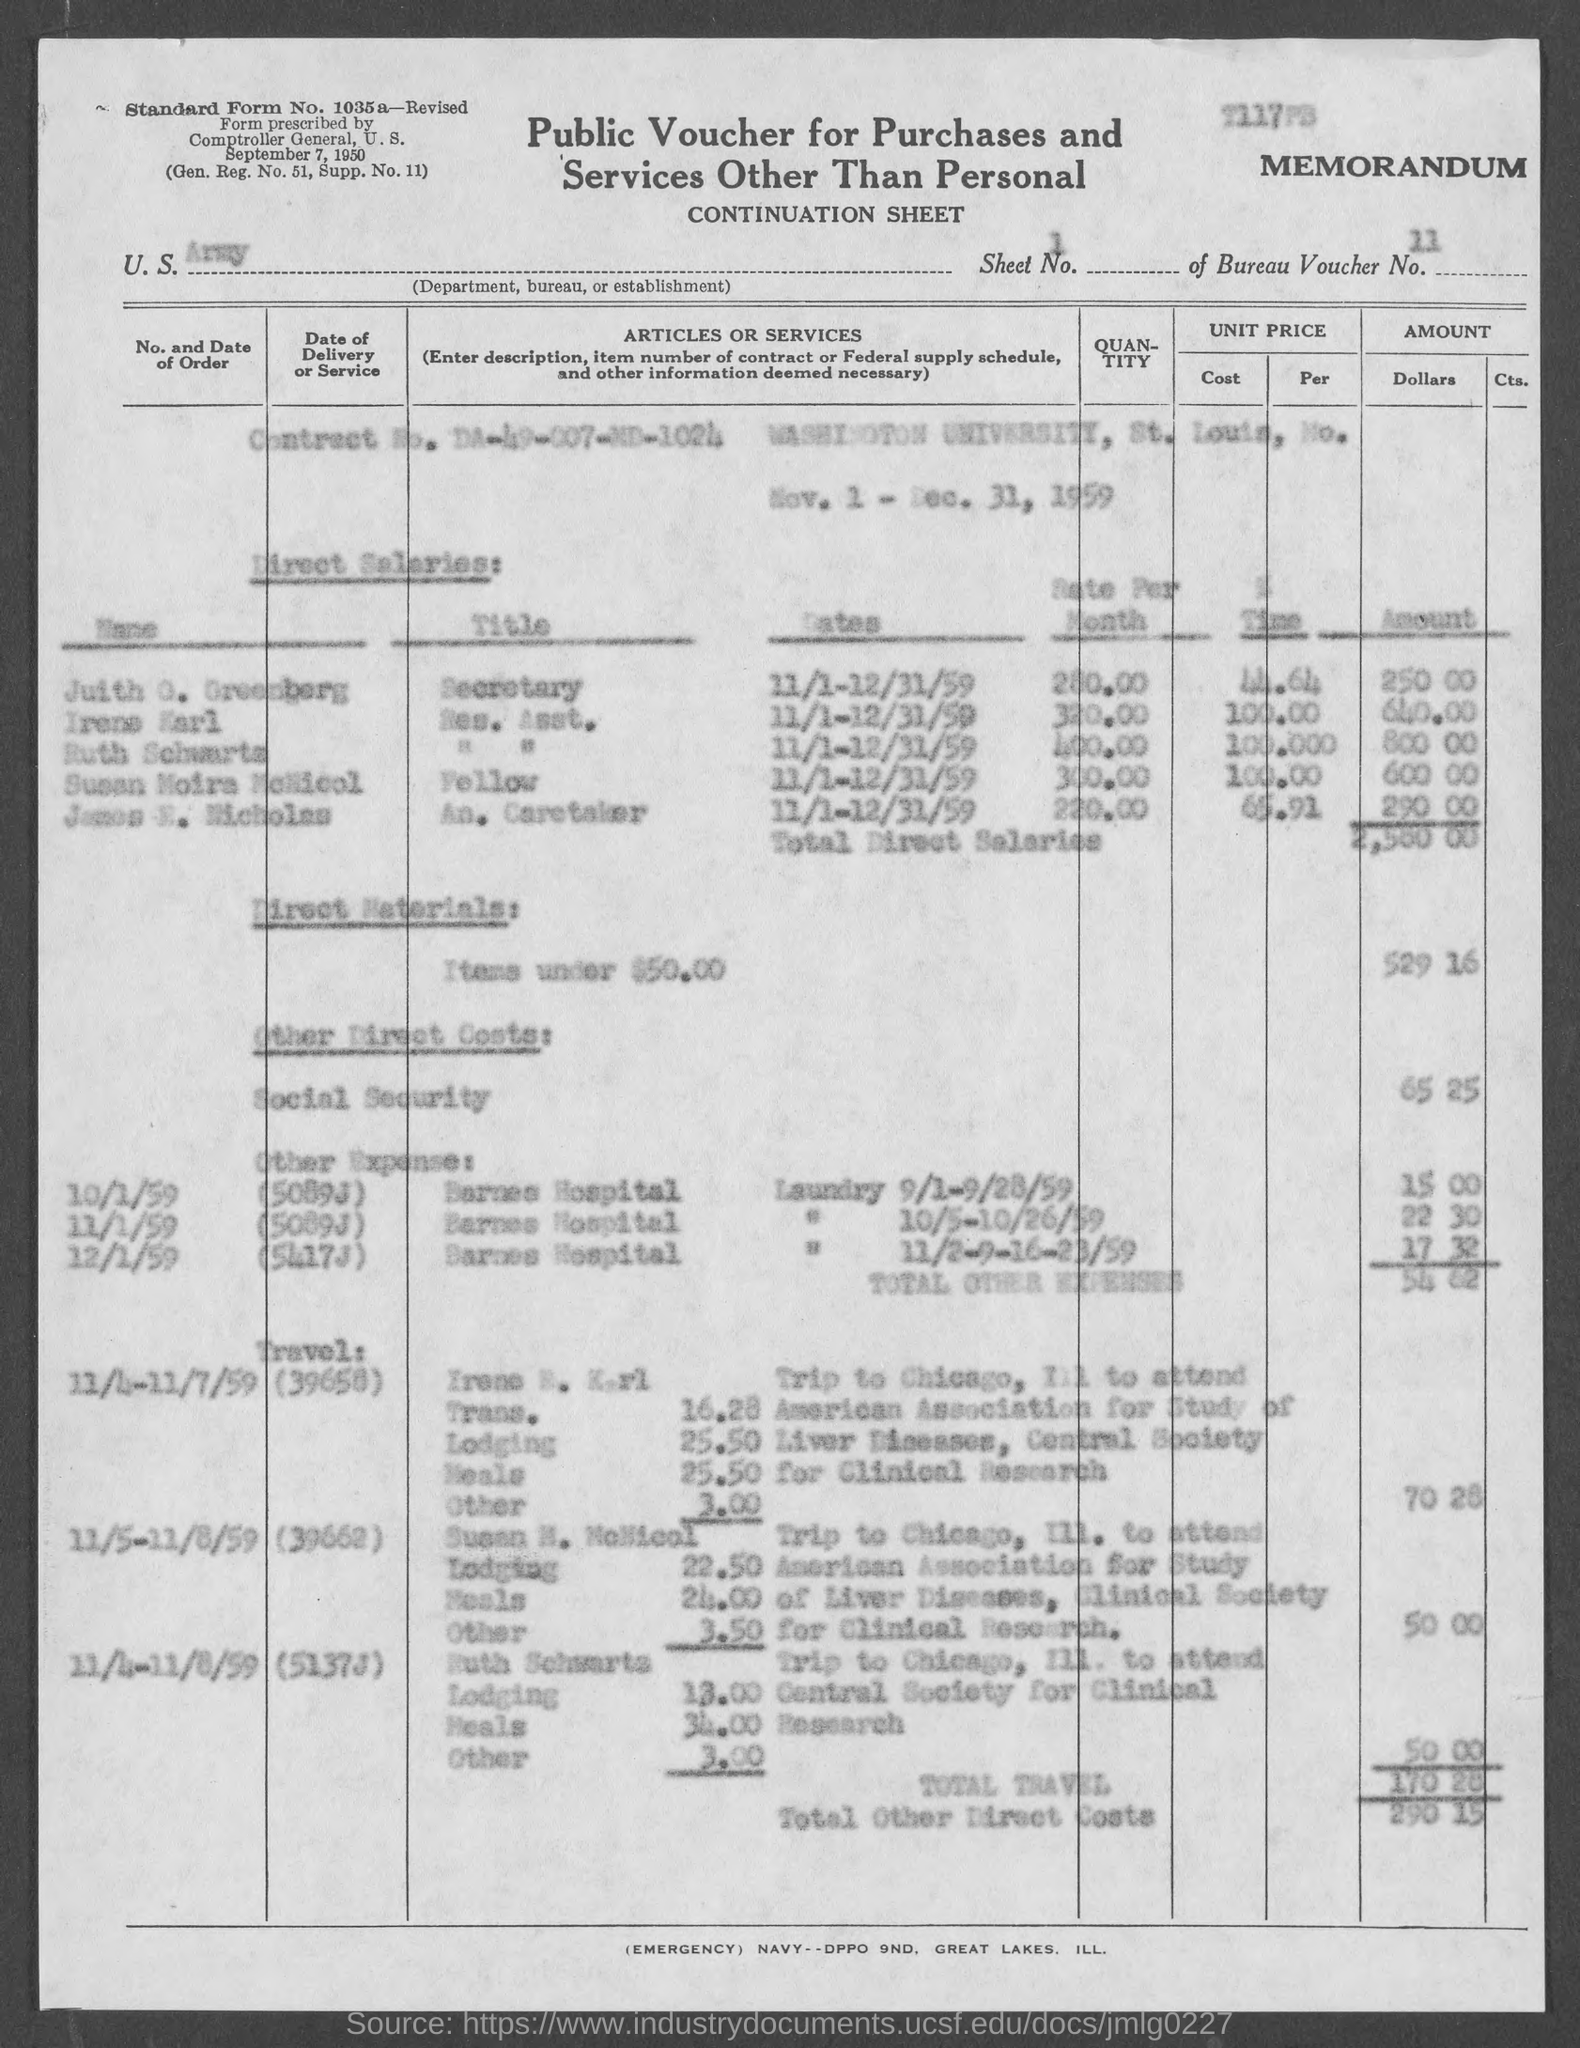What is the Standard Form No. given in the document?
Your answer should be compact. 1035a- Revised. What is the Sheet No. mentioned in the voucher?
Your answer should be very brief. 1. What is the Bureau Voucher No. given in the document?
Offer a terse response. 11. What is the Department, Bureau, or Establishment mentioned in the voucher?
Keep it short and to the point. U.S. Army. What is the Contract No. given in the voucher?
Ensure brevity in your answer.  DA-49-007-MD-1024. What is the Direct material cost (Items under $50) given in the document?
Offer a terse response. 529 16. What is the total travel cost mentioned in the voucher?
Provide a short and direct response. 170 28. 